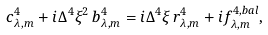<formula> <loc_0><loc_0><loc_500><loc_500>c ^ { 4 } _ { \lambda , m } + i \Delta ^ { 4 } \xi ^ { 2 } \, b ^ { 4 } _ { \lambda , m } = i \Delta ^ { 4 } \xi \, r ^ { 4 } _ { \lambda , m } + i f ^ { 4 , b a l } _ { \lambda , m } ,</formula> 